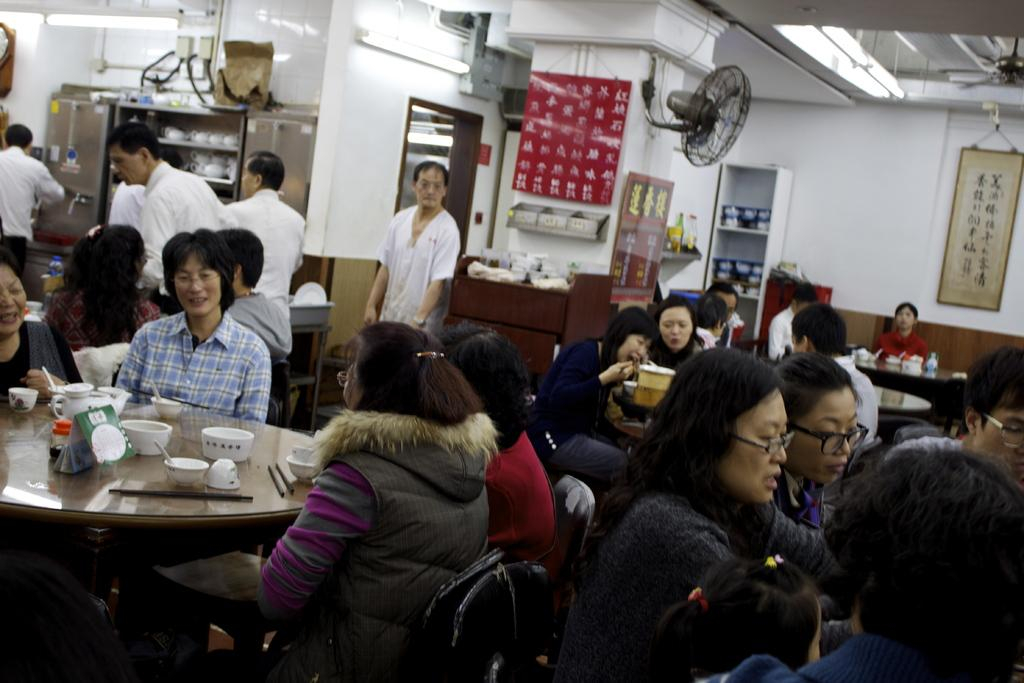What is happening in the image? There are people sitting around a table in the image. What can be seen in the background of the image? There is a fan, a banner, and a wall hanging in the background of the image. What type of road is visible in the image? There is no road visible in the image; it features people sitting around a table and elements in the background. 